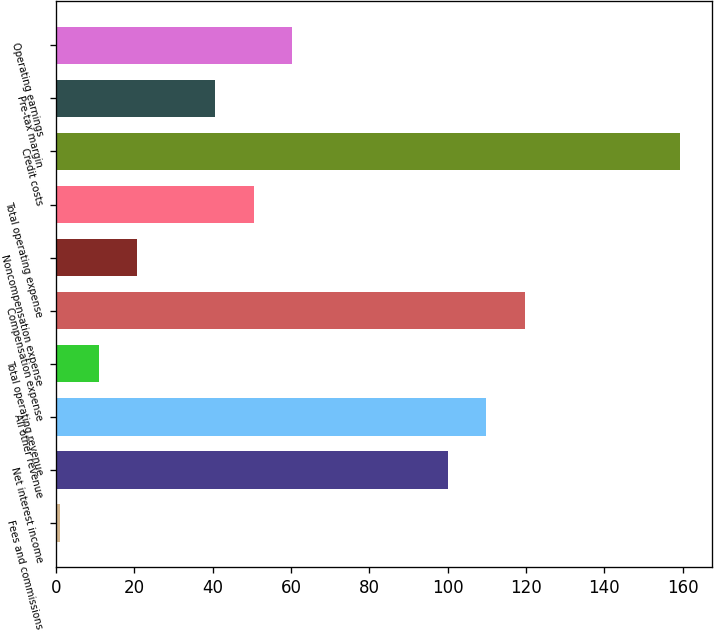Convert chart. <chart><loc_0><loc_0><loc_500><loc_500><bar_chart><fcel>Fees and commissions<fcel>Net interest income<fcel>All other revenue<fcel>Total operating revenue<fcel>Compensation expense<fcel>Noncompensation expense<fcel>Total operating expense<fcel>Credit costs<fcel>Pre-tax margin<fcel>Operating earnings<nl><fcel>1<fcel>100<fcel>109.9<fcel>10.9<fcel>119.8<fcel>20.8<fcel>50.5<fcel>159.4<fcel>40.6<fcel>60.4<nl></chart> 